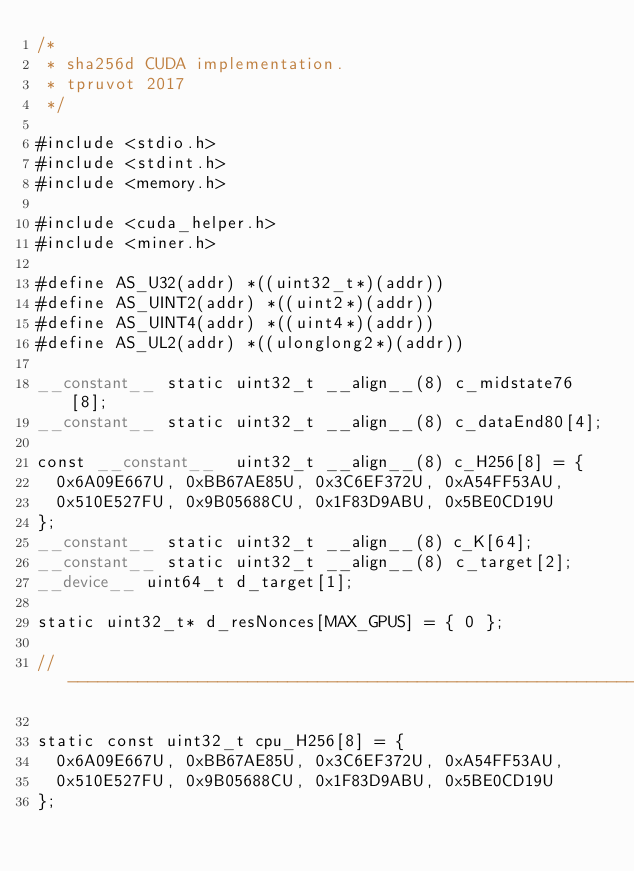<code> <loc_0><loc_0><loc_500><loc_500><_Cuda_>/*
 * sha256d CUDA implementation.
 * tpruvot 2017
 */

#include <stdio.h>
#include <stdint.h>
#include <memory.h>

#include <cuda_helper.h>
#include <miner.h>

#define AS_U32(addr) *((uint32_t*)(addr))
#define AS_UINT2(addr) *((uint2*)(addr))
#define AS_UINT4(addr) *((uint4*)(addr))
#define AS_UL2(addr) *((ulonglong2*)(addr))

__constant__ static uint32_t __align__(8) c_midstate76[8];
__constant__ static uint32_t __align__(8) c_dataEnd80[4];

const __constant__  uint32_t __align__(8) c_H256[8] = {
	0x6A09E667U, 0xBB67AE85U, 0x3C6EF372U, 0xA54FF53AU,
	0x510E527FU, 0x9B05688CU, 0x1F83D9ABU, 0x5BE0CD19U
};
__constant__ static uint32_t __align__(8) c_K[64];
__constant__ static uint32_t __align__(8) c_target[2];
__device__ uint64_t d_target[1];

static uint32_t* d_resNonces[MAX_GPUS] = { 0 };

// ------------------------------------------------------------------------------------------------

static const uint32_t cpu_H256[8] = {
	0x6A09E667U, 0xBB67AE85U, 0x3C6EF372U, 0xA54FF53AU,
	0x510E527FU, 0x9B05688CU, 0x1F83D9ABU, 0x5BE0CD19U
};
</code> 